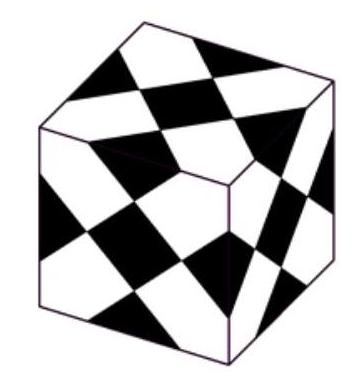How was the pattern on each face of the cube designed to ensure uniformity across all faces? Each face of the cube features triangles and trapezoids that are symmetrically aligned to maintain uniformity. The placement of the black squares follows a precise geometric distribution ensuring that when assembled into the cube form, the pattern on each face aligns seamlessly with its adjacent faces, creating a consistent overall appearance. The design likely involved careful measurement and planning to maintain this symmetry. 